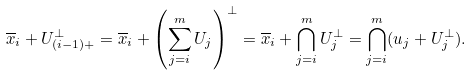<formula> <loc_0><loc_0><loc_500><loc_500>\overline { x } _ { i } + U ^ { \bot } _ { ( i - 1 ) + } = \overline { x } _ { i } + \left ( \sum _ { j = i } ^ { m } U _ { j } \right ) ^ { \bot } = \overline { x } _ { i } + \bigcap _ { j = i } ^ { m } U _ { j } ^ { \bot } = \bigcap _ { j = i } ^ { m } ( u _ { j } + U _ { j } ^ { \bot } ) .</formula> 